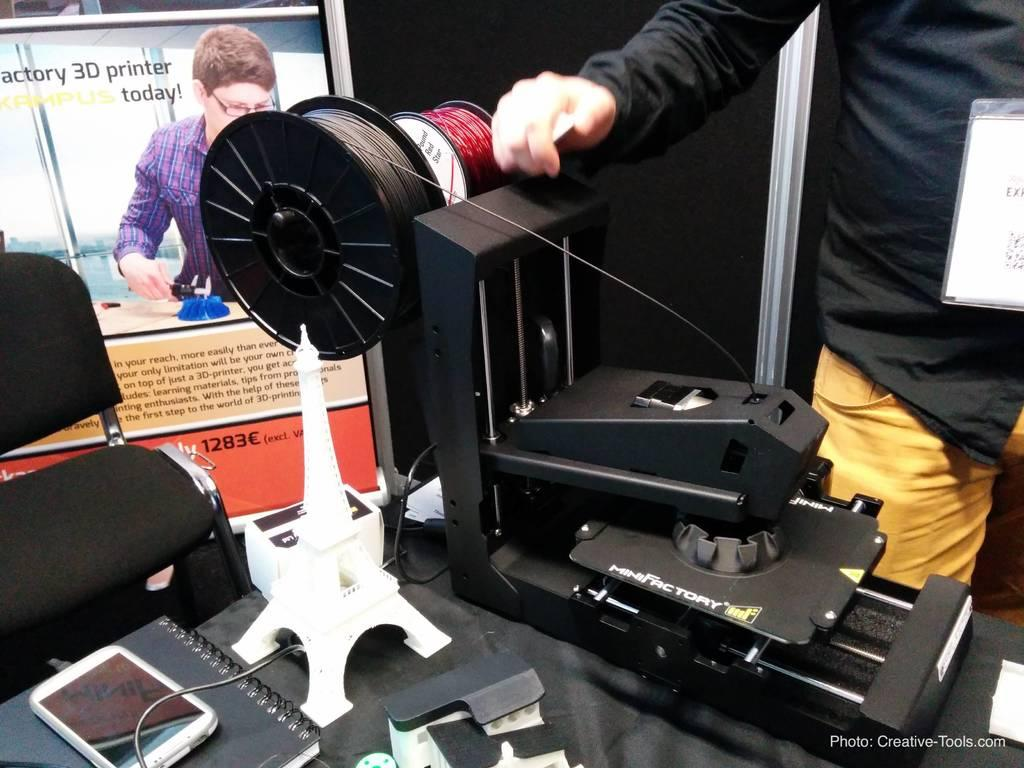What is the main subject of the image? There is a man standing in the image. What can be seen in the background of the image? There is a wall in the background of the image. What objects are present in the image? There is a tower, a mobile, a machine, a book, a chair, a poster, and a name board in the image. There are also some unspecified objects. What type of band is playing in the image? There is no band present in the image. Can you describe the treatment being administered to the man in the image? There is no treatment being administered to the man in the image. 